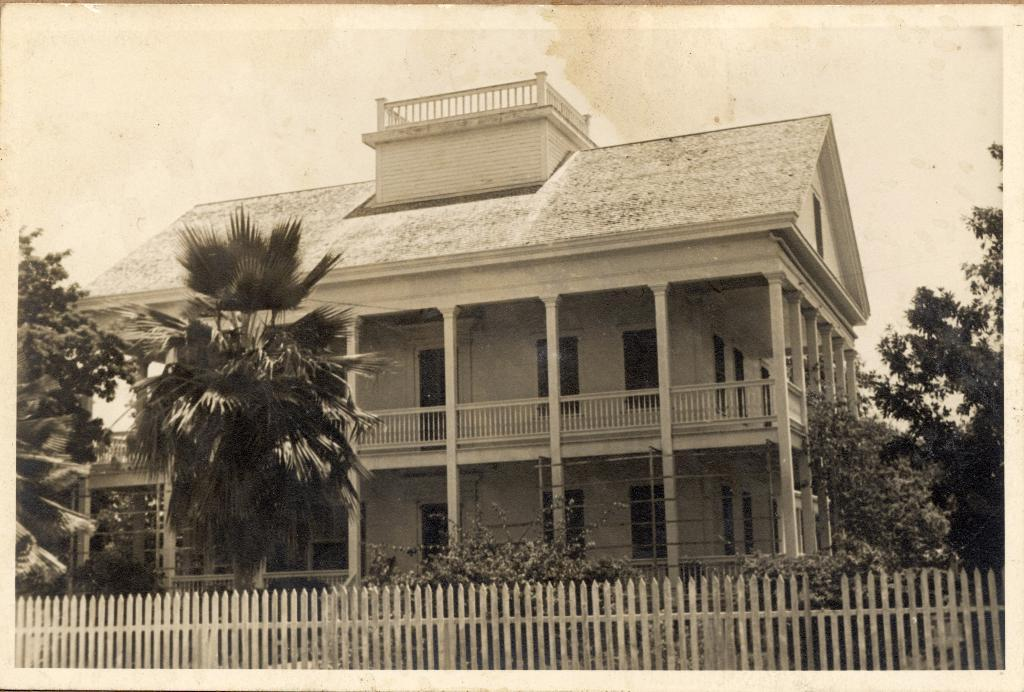What is located at the bottom of the image? There is a fence at the bottom of the image. What type of natural elements can be seen in the image? There are plants and trees in the image. What type of structure is visible in the background of the image? There is a building in the background of the image. What architectural features can be seen in the background of the image? There are doors, poles, and a roof in the background of the image. What part of the natural environment is visible in the image? The sky is visible in the background of the image. What type of bells can be heard ringing in the image? There are no bells present in the image, and therefore no sound can be heard. What advice does your uncle give in the image? There is no uncle present in the image, and therefore no advice can be given. 